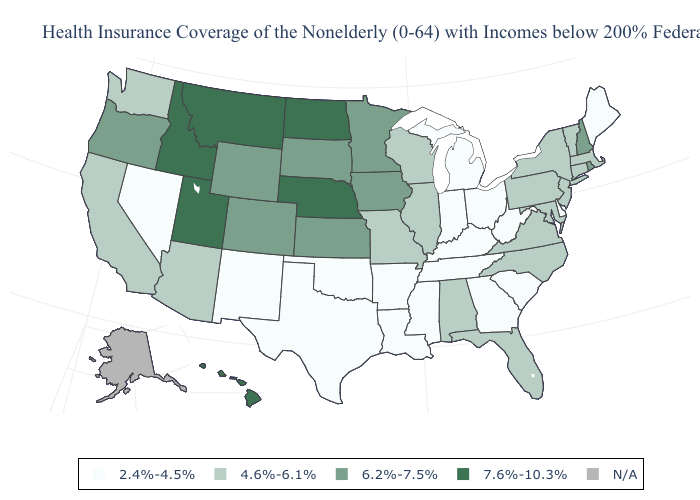Does the map have missing data?
Quick response, please. Yes. Among the states that border Vermont , which have the highest value?
Keep it brief. New Hampshire. Among the states that border Florida , which have the highest value?
Keep it brief. Alabama. What is the lowest value in states that border Maryland?
Answer briefly. 2.4%-4.5%. Name the states that have a value in the range 6.2%-7.5%?
Quick response, please. Colorado, Iowa, Kansas, Minnesota, New Hampshire, Oregon, Rhode Island, South Dakota, Wyoming. What is the highest value in the West ?
Be succinct. 7.6%-10.3%. What is the value of New Mexico?
Write a very short answer. 2.4%-4.5%. What is the highest value in the USA?
Short answer required. 7.6%-10.3%. Which states have the lowest value in the USA?
Concise answer only. Arkansas, Delaware, Georgia, Indiana, Kentucky, Louisiana, Maine, Michigan, Mississippi, Nevada, New Mexico, Ohio, Oklahoma, South Carolina, Tennessee, Texas, West Virginia. Does New York have the lowest value in the Northeast?
Answer briefly. No. What is the value of Hawaii?
Concise answer only. 7.6%-10.3%. Name the states that have a value in the range 4.6%-6.1%?
Answer briefly. Alabama, Arizona, California, Connecticut, Florida, Illinois, Maryland, Massachusetts, Missouri, New Jersey, New York, North Carolina, Pennsylvania, Vermont, Virginia, Washington, Wisconsin. Does North Dakota have the highest value in the MidWest?
Give a very brief answer. Yes. 